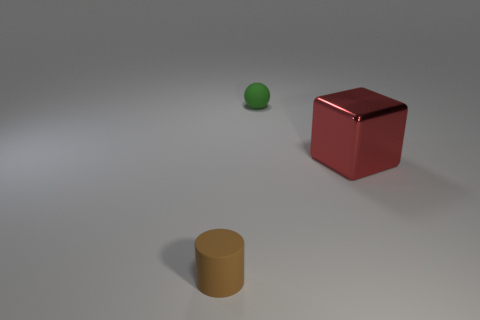What is the shape of the green thing that is the same size as the brown object?
Give a very brief answer. Sphere. Are there any yellow shiny spheres that have the same size as the brown object?
Keep it short and to the point. No. Are there more tiny green matte spheres to the right of the red thing than things to the right of the small green rubber ball?
Give a very brief answer. No. Does the small brown cylinder have the same material as the block that is in front of the small green matte ball?
Your answer should be very brief. No. What number of large red objects are on the right side of the tiny matte object on the left side of the thing that is behind the large metallic object?
Provide a short and direct response. 1. What is the color of the object that is to the right of the small brown matte cylinder and in front of the green object?
Keep it short and to the point. Red. What is the material of the thing that is right of the small matte thing behind the thing in front of the block?
Offer a terse response. Metal. What is the material of the brown object?
Keep it short and to the point. Rubber. What number of other things are made of the same material as the red object?
Your response must be concise. 0. Are there an equal number of small brown objects on the left side of the big metal cube and cylinders?
Give a very brief answer. Yes. 